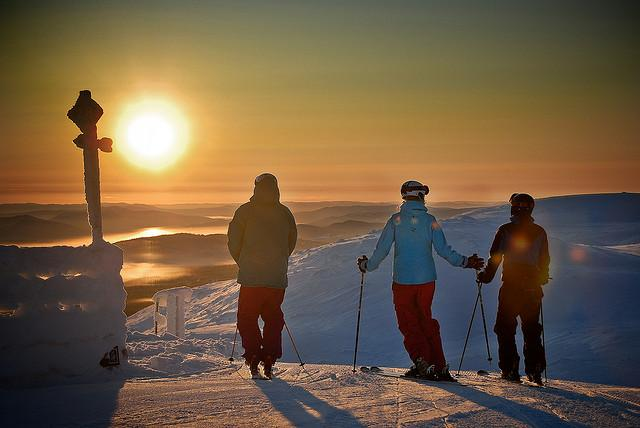What are the skiers watching? sunset 